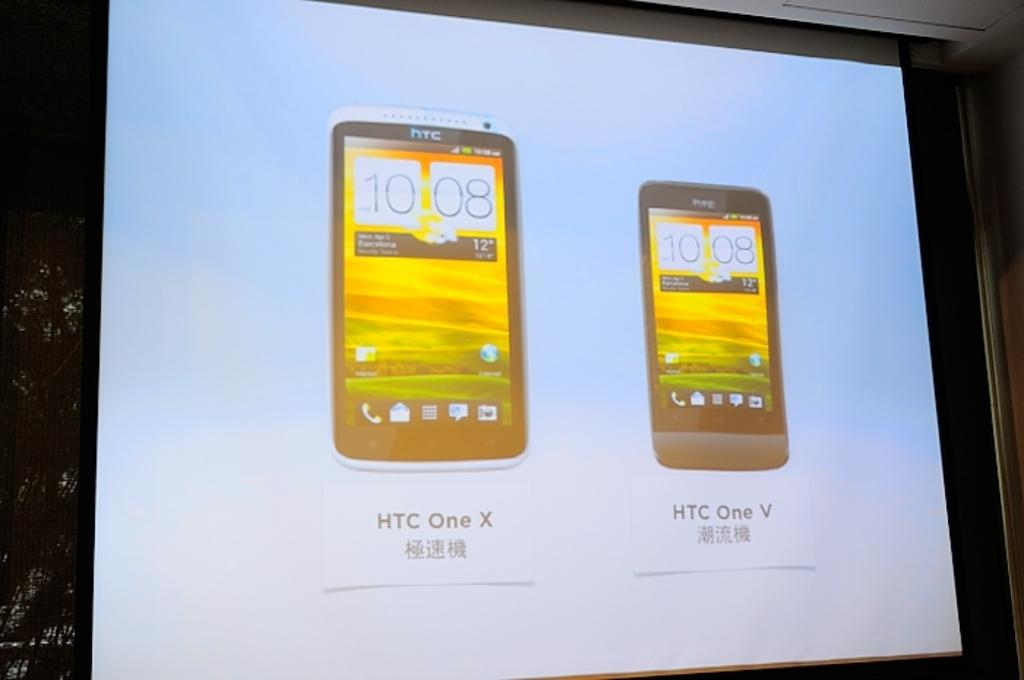What is the main subject of the image? The main subject of the image is a projected screen. What is being displayed on the projected screen? The projected screen displays pictures of a mobile phone. Can you describe the background of the image? The background of the image is dark. How many oranges are visible on the projected screen? There are no oranges visible on the projected screen; it displays pictures of a mobile phone. Is there a mask present on the projected screen? There is no mask present on the projected screen; it displays pictures of a mobile phone. 